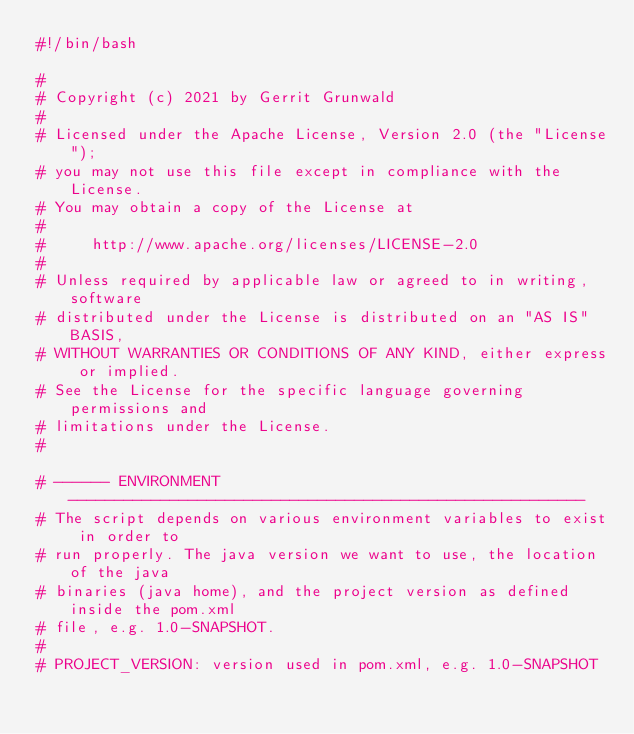<code> <loc_0><loc_0><loc_500><loc_500><_Bash_>#!/bin/bash

#
# Copyright (c) 2021 by Gerrit Grunwald
#
# Licensed under the Apache License, Version 2.0 (the "License");
# you may not use this file except in compliance with the License.
# You may obtain a copy of the License at
#
#     http://www.apache.org/licenses/LICENSE-2.0
#
# Unless required by applicable law or agreed to in writing, software
# distributed under the License is distributed on an "AS IS" BASIS,
# WITHOUT WARRANTIES OR CONDITIONS OF ANY KIND, either express or implied.
# See the License for the specific language governing permissions and
# limitations under the License.
#

# ------ ENVIRONMENT --------------------------------------------------------
# The script depends on various environment variables to exist in order to
# run properly. The java version we want to use, the location of the java
# binaries (java home), and the project version as defined inside the pom.xml
# file, e.g. 1.0-SNAPSHOT.
#
# PROJECT_VERSION: version used in pom.xml, e.g. 1.0-SNAPSHOT</code> 